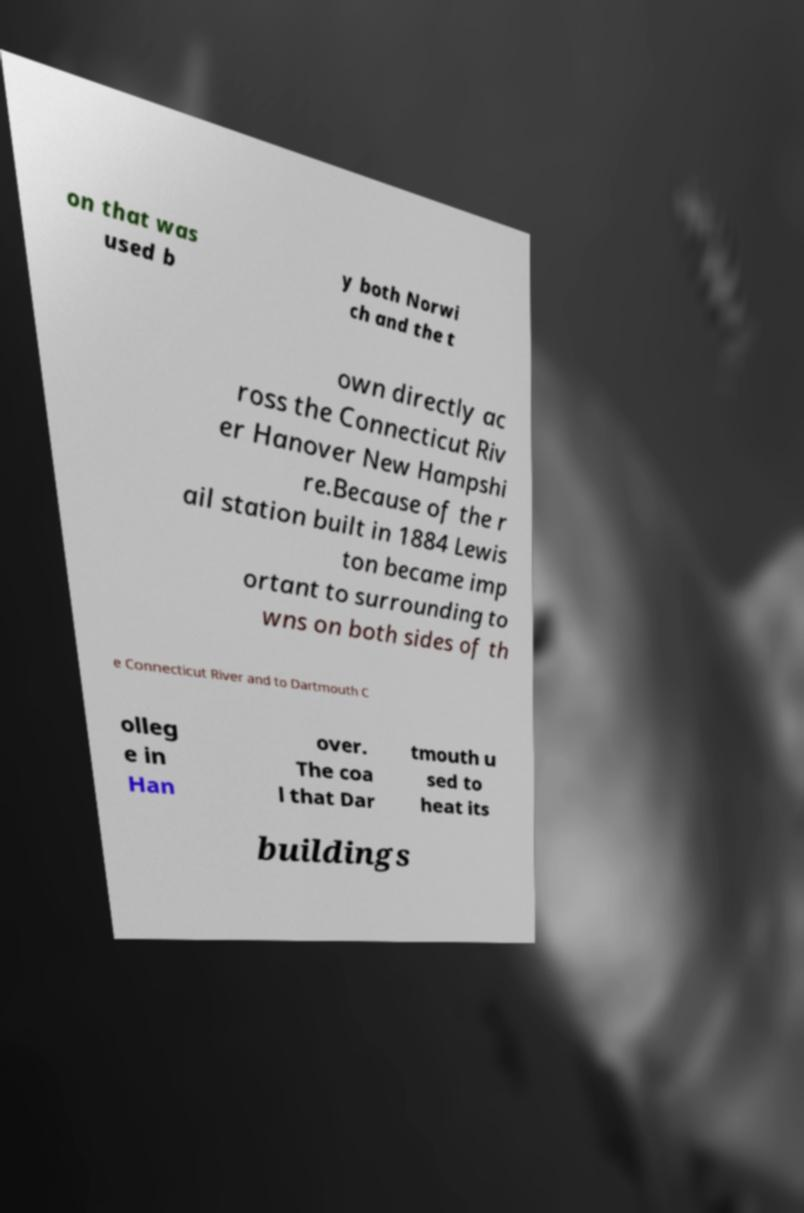Please identify and transcribe the text found in this image. on that was used b y both Norwi ch and the t own directly ac ross the Connecticut Riv er Hanover New Hampshi re.Because of the r ail station built in 1884 Lewis ton became imp ortant to surrounding to wns on both sides of th e Connecticut River and to Dartmouth C olleg e in Han over. The coa l that Dar tmouth u sed to heat its buildings 